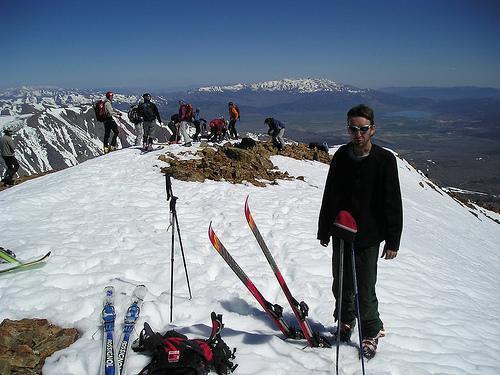How many people are in the picture?
Give a very brief answer. 11. How many skis are on the ground?
Give a very brief answer. 5. 